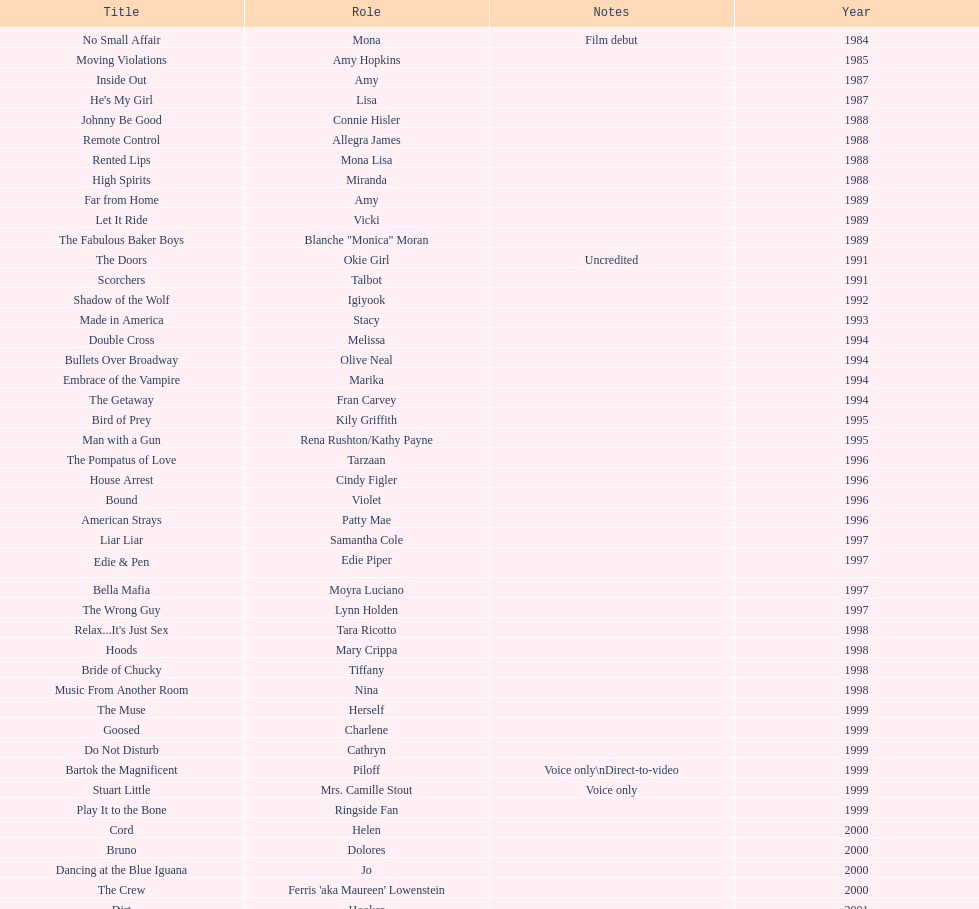Which film has their role under igiyook? Shadow of the Wolf. 